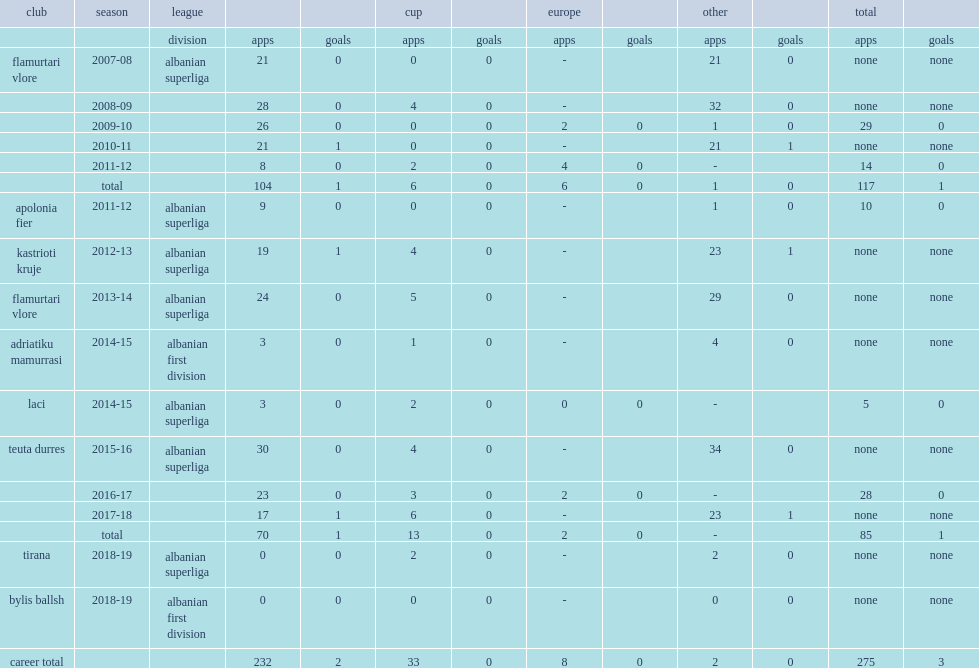Which club did mocka play for in 2011-12? Apolonia fier. 